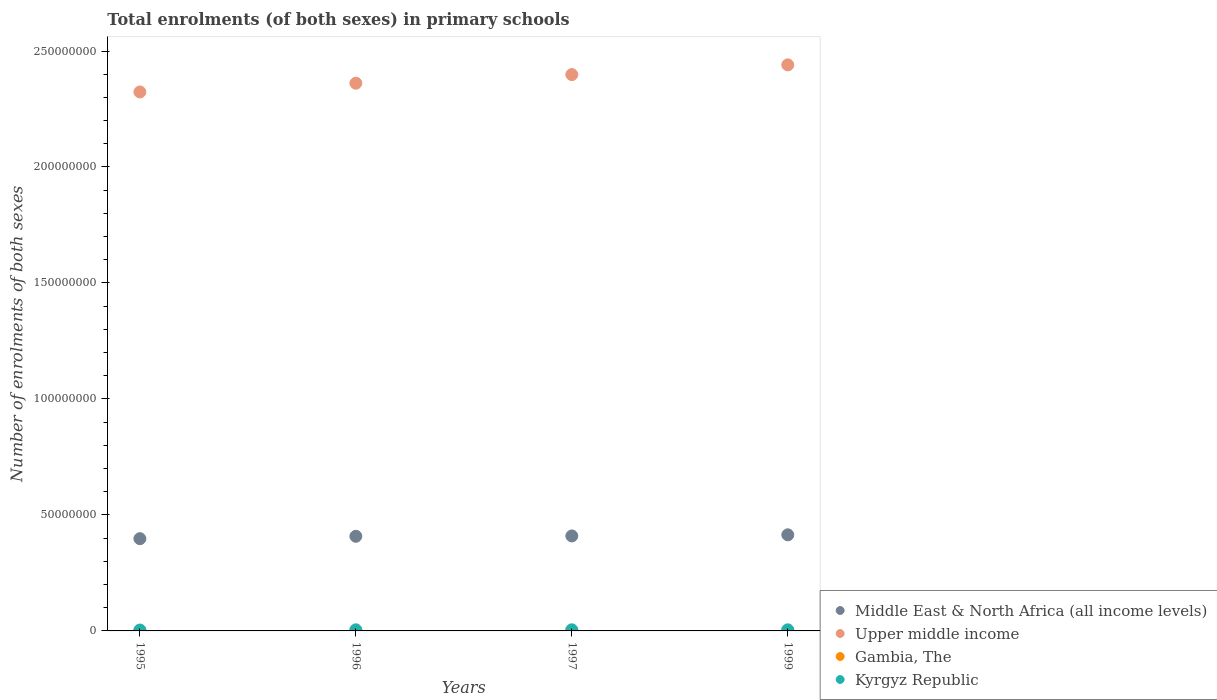Is the number of dotlines equal to the number of legend labels?
Make the answer very short. Yes. What is the number of enrolments in primary schools in Upper middle income in 1997?
Provide a short and direct response. 2.40e+08. Across all years, what is the maximum number of enrolments in primary schools in Gambia, The?
Give a very brief answer. 1.70e+05. Across all years, what is the minimum number of enrolments in primary schools in Middle East & North Africa (all income levels)?
Offer a terse response. 3.98e+07. In which year was the number of enrolments in primary schools in Upper middle income maximum?
Ensure brevity in your answer.  1999. In which year was the number of enrolments in primary schools in Gambia, The minimum?
Offer a very short reply. 1995. What is the total number of enrolments in primary schools in Kyrgyz Republic in the graph?
Your answer should be very brief. 1.81e+06. What is the difference between the number of enrolments in primary schools in Upper middle income in 1996 and that in 1999?
Give a very brief answer. -7.90e+06. What is the difference between the number of enrolments in primary schools in Kyrgyz Republic in 1995 and the number of enrolments in primary schools in Middle East & North Africa (all income levels) in 1997?
Keep it short and to the point. -4.06e+07. What is the average number of enrolments in primary schools in Gambia, The per year?
Give a very brief answer. 1.35e+05. In the year 1999, what is the difference between the number of enrolments in primary schools in Gambia, The and number of enrolments in primary schools in Middle East & North Africa (all income levels)?
Give a very brief answer. -4.13e+07. What is the ratio of the number of enrolments in primary schools in Gambia, The in 1996 to that in 1999?
Provide a short and direct response. 0.73. Is the number of enrolments in primary schools in Gambia, The in 1997 less than that in 1999?
Make the answer very short. Yes. What is the difference between the highest and the second highest number of enrolments in primary schools in Upper middle income?
Provide a short and direct response. 4.20e+06. What is the difference between the highest and the lowest number of enrolments in primary schools in Gambia, The?
Your answer should be compact. 5.71e+04. Is it the case that in every year, the sum of the number of enrolments in primary schools in Upper middle income and number of enrolments in primary schools in Kyrgyz Republic  is greater than the number of enrolments in primary schools in Gambia, The?
Provide a succinct answer. Yes. Is the number of enrolments in primary schools in Gambia, The strictly greater than the number of enrolments in primary schools in Middle East & North Africa (all income levels) over the years?
Offer a terse response. No. How many dotlines are there?
Provide a short and direct response. 4. How many years are there in the graph?
Make the answer very short. 4. What is the difference between two consecutive major ticks on the Y-axis?
Offer a terse response. 5.00e+07. Are the values on the major ticks of Y-axis written in scientific E-notation?
Your response must be concise. No. Does the graph contain any zero values?
Offer a very short reply. No. Does the graph contain grids?
Your answer should be compact. No. How many legend labels are there?
Provide a succinct answer. 4. What is the title of the graph?
Make the answer very short. Total enrolments (of both sexes) in primary schools. Does "Low income" appear as one of the legend labels in the graph?
Ensure brevity in your answer.  No. What is the label or title of the X-axis?
Offer a terse response. Years. What is the label or title of the Y-axis?
Your response must be concise. Number of enrolments of both sexes. What is the Number of enrolments of both sexes in Middle East & North Africa (all income levels) in 1995?
Make the answer very short. 3.98e+07. What is the Number of enrolments of both sexes in Upper middle income in 1995?
Your answer should be very brief. 2.32e+08. What is the Number of enrolments of both sexes in Gambia, The in 1995?
Your answer should be very brief. 1.13e+05. What is the Number of enrolments of both sexes of Kyrgyz Republic in 1995?
Give a very brief answer. 3.88e+05. What is the Number of enrolments of both sexes of Middle East & North Africa (all income levels) in 1996?
Your response must be concise. 4.08e+07. What is the Number of enrolments of both sexes of Upper middle income in 1996?
Your response must be concise. 2.36e+08. What is the Number of enrolments of both sexes of Gambia, The in 1996?
Offer a very short reply. 1.25e+05. What is the Number of enrolments of both sexes in Kyrgyz Republic in 1996?
Ensure brevity in your answer.  4.73e+05. What is the Number of enrolments of both sexes in Middle East & North Africa (all income levels) in 1997?
Your response must be concise. 4.09e+07. What is the Number of enrolments of both sexes of Upper middle income in 1997?
Keep it short and to the point. 2.40e+08. What is the Number of enrolments of both sexes of Gambia, The in 1997?
Give a very brief answer. 1.33e+05. What is the Number of enrolments of both sexes of Kyrgyz Republic in 1997?
Provide a succinct answer. 4.78e+05. What is the Number of enrolments of both sexes in Middle East & North Africa (all income levels) in 1999?
Make the answer very short. 4.14e+07. What is the Number of enrolments of both sexes in Upper middle income in 1999?
Give a very brief answer. 2.44e+08. What is the Number of enrolments of both sexes in Gambia, The in 1999?
Offer a terse response. 1.70e+05. What is the Number of enrolments of both sexes in Kyrgyz Republic in 1999?
Ensure brevity in your answer.  4.70e+05. Across all years, what is the maximum Number of enrolments of both sexes in Middle East & North Africa (all income levels)?
Your answer should be very brief. 4.14e+07. Across all years, what is the maximum Number of enrolments of both sexes in Upper middle income?
Keep it short and to the point. 2.44e+08. Across all years, what is the maximum Number of enrolments of both sexes of Gambia, The?
Ensure brevity in your answer.  1.70e+05. Across all years, what is the maximum Number of enrolments of both sexes of Kyrgyz Republic?
Your answer should be compact. 4.78e+05. Across all years, what is the minimum Number of enrolments of both sexes in Middle East & North Africa (all income levels)?
Offer a terse response. 3.98e+07. Across all years, what is the minimum Number of enrolments of both sexes of Upper middle income?
Give a very brief answer. 2.32e+08. Across all years, what is the minimum Number of enrolments of both sexes of Gambia, The?
Ensure brevity in your answer.  1.13e+05. Across all years, what is the minimum Number of enrolments of both sexes in Kyrgyz Republic?
Offer a very short reply. 3.88e+05. What is the total Number of enrolments of both sexes of Middle East & North Africa (all income levels) in the graph?
Offer a terse response. 1.63e+08. What is the total Number of enrolments of both sexes in Upper middle income in the graph?
Keep it short and to the point. 9.52e+08. What is the total Number of enrolments of both sexes in Gambia, The in the graph?
Offer a terse response. 5.42e+05. What is the total Number of enrolments of both sexes in Kyrgyz Republic in the graph?
Provide a succinct answer. 1.81e+06. What is the difference between the Number of enrolments of both sexes in Middle East & North Africa (all income levels) in 1995 and that in 1996?
Your response must be concise. -1.03e+06. What is the difference between the Number of enrolments of both sexes in Upper middle income in 1995 and that in 1996?
Your answer should be very brief. -3.78e+06. What is the difference between the Number of enrolments of both sexes in Gambia, The in 1995 and that in 1996?
Keep it short and to the point. -1.13e+04. What is the difference between the Number of enrolments of both sexes in Kyrgyz Republic in 1995 and that in 1996?
Your answer should be compact. -8.59e+04. What is the difference between the Number of enrolments of both sexes of Middle East & North Africa (all income levels) in 1995 and that in 1997?
Your response must be concise. -1.18e+06. What is the difference between the Number of enrolments of both sexes in Upper middle income in 1995 and that in 1997?
Ensure brevity in your answer.  -7.49e+06. What is the difference between the Number of enrolments of both sexes in Gambia, The in 1995 and that in 1997?
Provide a short and direct response. -2.02e+04. What is the difference between the Number of enrolments of both sexes in Kyrgyz Republic in 1995 and that in 1997?
Your response must be concise. -9.03e+04. What is the difference between the Number of enrolments of both sexes of Middle East & North Africa (all income levels) in 1995 and that in 1999?
Provide a succinct answer. -1.67e+06. What is the difference between the Number of enrolments of both sexes in Upper middle income in 1995 and that in 1999?
Offer a terse response. -1.17e+07. What is the difference between the Number of enrolments of both sexes of Gambia, The in 1995 and that in 1999?
Ensure brevity in your answer.  -5.71e+04. What is the difference between the Number of enrolments of both sexes in Kyrgyz Republic in 1995 and that in 1999?
Make the answer very short. -8.22e+04. What is the difference between the Number of enrolments of both sexes in Middle East & North Africa (all income levels) in 1996 and that in 1997?
Offer a very short reply. -1.48e+05. What is the difference between the Number of enrolments of both sexes of Upper middle income in 1996 and that in 1997?
Your answer should be very brief. -3.71e+06. What is the difference between the Number of enrolments of both sexes of Gambia, The in 1996 and that in 1997?
Give a very brief answer. -8896. What is the difference between the Number of enrolments of both sexes in Kyrgyz Republic in 1996 and that in 1997?
Make the answer very short. -4451. What is the difference between the Number of enrolments of both sexes in Middle East & North Africa (all income levels) in 1996 and that in 1999?
Ensure brevity in your answer.  -6.35e+05. What is the difference between the Number of enrolments of both sexes of Upper middle income in 1996 and that in 1999?
Your answer should be very brief. -7.90e+06. What is the difference between the Number of enrolments of both sexes in Gambia, The in 1996 and that in 1999?
Offer a terse response. -4.59e+04. What is the difference between the Number of enrolments of both sexes in Kyrgyz Republic in 1996 and that in 1999?
Your answer should be very brief. 3684. What is the difference between the Number of enrolments of both sexes of Middle East & North Africa (all income levels) in 1997 and that in 1999?
Provide a short and direct response. -4.87e+05. What is the difference between the Number of enrolments of both sexes in Upper middle income in 1997 and that in 1999?
Give a very brief answer. -4.20e+06. What is the difference between the Number of enrolments of both sexes in Gambia, The in 1997 and that in 1999?
Ensure brevity in your answer.  -3.70e+04. What is the difference between the Number of enrolments of both sexes of Kyrgyz Republic in 1997 and that in 1999?
Your answer should be very brief. 8135. What is the difference between the Number of enrolments of both sexes of Middle East & North Africa (all income levels) in 1995 and the Number of enrolments of both sexes of Upper middle income in 1996?
Make the answer very short. -1.96e+08. What is the difference between the Number of enrolments of both sexes in Middle East & North Africa (all income levels) in 1995 and the Number of enrolments of both sexes in Gambia, The in 1996?
Ensure brevity in your answer.  3.96e+07. What is the difference between the Number of enrolments of both sexes in Middle East & North Africa (all income levels) in 1995 and the Number of enrolments of both sexes in Kyrgyz Republic in 1996?
Your response must be concise. 3.93e+07. What is the difference between the Number of enrolments of both sexes in Upper middle income in 1995 and the Number of enrolments of both sexes in Gambia, The in 1996?
Your response must be concise. 2.32e+08. What is the difference between the Number of enrolments of both sexes in Upper middle income in 1995 and the Number of enrolments of both sexes in Kyrgyz Republic in 1996?
Your answer should be compact. 2.32e+08. What is the difference between the Number of enrolments of both sexes of Gambia, The in 1995 and the Number of enrolments of both sexes of Kyrgyz Republic in 1996?
Give a very brief answer. -3.60e+05. What is the difference between the Number of enrolments of both sexes of Middle East & North Africa (all income levels) in 1995 and the Number of enrolments of both sexes of Upper middle income in 1997?
Provide a succinct answer. -2.00e+08. What is the difference between the Number of enrolments of both sexes in Middle East & North Africa (all income levels) in 1995 and the Number of enrolments of both sexes in Gambia, The in 1997?
Ensure brevity in your answer.  3.96e+07. What is the difference between the Number of enrolments of both sexes of Middle East & North Africa (all income levels) in 1995 and the Number of enrolments of both sexes of Kyrgyz Republic in 1997?
Keep it short and to the point. 3.93e+07. What is the difference between the Number of enrolments of both sexes in Upper middle income in 1995 and the Number of enrolments of both sexes in Gambia, The in 1997?
Give a very brief answer. 2.32e+08. What is the difference between the Number of enrolments of both sexes of Upper middle income in 1995 and the Number of enrolments of both sexes of Kyrgyz Republic in 1997?
Provide a short and direct response. 2.32e+08. What is the difference between the Number of enrolments of both sexes of Gambia, The in 1995 and the Number of enrolments of both sexes of Kyrgyz Republic in 1997?
Make the answer very short. -3.65e+05. What is the difference between the Number of enrolments of both sexes of Middle East & North Africa (all income levels) in 1995 and the Number of enrolments of both sexes of Upper middle income in 1999?
Your answer should be compact. -2.04e+08. What is the difference between the Number of enrolments of both sexes of Middle East & North Africa (all income levels) in 1995 and the Number of enrolments of both sexes of Gambia, The in 1999?
Ensure brevity in your answer.  3.96e+07. What is the difference between the Number of enrolments of both sexes of Middle East & North Africa (all income levels) in 1995 and the Number of enrolments of both sexes of Kyrgyz Republic in 1999?
Provide a succinct answer. 3.93e+07. What is the difference between the Number of enrolments of both sexes of Upper middle income in 1995 and the Number of enrolments of both sexes of Gambia, The in 1999?
Give a very brief answer. 2.32e+08. What is the difference between the Number of enrolments of both sexes of Upper middle income in 1995 and the Number of enrolments of both sexes of Kyrgyz Republic in 1999?
Make the answer very short. 2.32e+08. What is the difference between the Number of enrolments of both sexes in Gambia, The in 1995 and the Number of enrolments of both sexes in Kyrgyz Republic in 1999?
Your answer should be very brief. -3.57e+05. What is the difference between the Number of enrolments of both sexes in Middle East & North Africa (all income levels) in 1996 and the Number of enrolments of both sexes in Upper middle income in 1997?
Keep it short and to the point. -1.99e+08. What is the difference between the Number of enrolments of both sexes of Middle East & North Africa (all income levels) in 1996 and the Number of enrolments of both sexes of Gambia, The in 1997?
Your answer should be compact. 4.07e+07. What is the difference between the Number of enrolments of both sexes of Middle East & North Africa (all income levels) in 1996 and the Number of enrolments of both sexes of Kyrgyz Republic in 1997?
Offer a very short reply. 4.03e+07. What is the difference between the Number of enrolments of both sexes in Upper middle income in 1996 and the Number of enrolments of both sexes in Gambia, The in 1997?
Make the answer very short. 2.36e+08. What is the difference between the Number of enrolments of both sexes of Upper middle income in 1996 and the Number of enrolments of both sexes of Kyrgyz Republic in 1997?
Provide a short and direct response. 2.36e+08. What is the difference between the Number of enrolments of both sexes in Gambia, The in 1996 and the Number of enrolments of both sexes in Kyrgyz Republic in 1997?
Keep it short and to the point. -3.53e+05. What is the difference between the Number of enrolments of both sexes of Middle East & North Africa (all income levels) in 1996 and the Number of enrolments of both sexes of Upper middle income in 1999?
Provide a succinct answer. -2.03e+08. What is the difference between the Number of enrolments of both sexes of Middle East & North Africa (all income levels) in 1996 and the Number of enrolments of both sexes of Gambia, The in 1999?
Make the answer very short. 4.06e+07. What is the difference between the Number of enrolments of both sexes in Middle East & North Africa (all income levels) in 1996 and the Number of enrolments of both sexes in Kyrgyz Republic in 1999?
Ensure brevity in your answer.  4.03e+07. What is the difference between the Number of enrolments of both sexes in Upper middle income in 1996 and the Number of enrolments of both sexes in Gambia, The in 1999?
Provide a succinct answer. 2.36e+08. What is the difference between the Number of enrolments of both sexes of Upper middle income in 1996 and the Number of enrolments of both sexes of Kyrgyz Republic in 1999?
Keep it short and to the point. 2.36e+08. What is the difference between the Number of enrolments of both sexes in Gambia, The in 1996 and the Number of enrolments of both sexes in Kyrgyz Republic in 1999?
Provide a succinct answer. -3.45e+05. What is the difference between the Number of enrolments of both sexes in Middle East & North Africa (all income levels) in 1997 and the Number of enrolments of both sexes in Upper middle income in 1999?
Offer a very short reply. -2.03e+08. What is the difference between the Number of enrolments of both sexes in Middle East & North Africa (all income levels) in 1997 and the Number of enrolments of both sexes in Gambia, The in 1999?
Keep it short and to the point. 4.08e+07. What is the difference between the Number of enrolments of both sexes of Middle East & North Africa (all income levels) in 1997 and the Number of enrolments of both sexes of Kyrgyz Republic in 1999?
Ensure brevity in your answer.  4.05e+07. What is the difference between the Number of enrolments of both sexes of Upper middle income in 1997 and the Number of enrolments of both sexes of Gambia, The in 1999?
Your answer should be very brief. 2.40e+08. What is the difference between the Number of enrolments of both sexes of Upper middle income in 1997 and the Number of enrolments of both sexes of Kyrgyz Republic in 1999?
Your response must be concise. 2.39e+08. What is the difference between the Number of enrolments of both sexes in Gambia, The in 1997 and the Number of enrolments of both sexes in Kyrgyz Republic in 1999?
Your response must be concise. -3.36e+05. What is the average Number of enrolments of both sexes of Middle East & North Africa (all income levels) per year?
Your answer should be compact. 4.07e+07. What is the average Number of enrolments of both sexes in Upper middle income per year?
Give a very brief answer. 2.38e+08. What is the average Number of enrolments of both sexes of Gambia, The per year?
Offer a very short reply. 1.35e+05. What is the average Number of enrolments of both sexes of Kyrgyz Republic per year?
Keep it short and to the point. 4.52e+05. In the year 1995, what is the difference between the Number of enrolments of both sexes in Middle East & North Africa (all income levels) and Number of enrolments of both sexes in Upper middle income?
Provide a succinct answer. -1.93e+08. In the year 1995, what is the difference between the Number of enrolments of both sexes in Middle East & North Africa (all income levels) and Number of enrolments of both sexes in Gambia, The?
Give a very brief answer. 3.97e+07. In the year 1995, what is the difference between the Number of enrolments of both sexes in Middle East & North Africa (all income levels) and Number of enrolments of both sexes in Kyrgyz Republic?
Your answer should be very brief. 3.94e+07. In the year 1995, what is the difference between the Number of enrolments of both sexes in Upper middle income and Number of enrolments of both sexes in Gambia, The?
Your answer should be compact. 2.32e+08. In the year 1995, what is the difference between the Number of enrolments of both sexes of Upper middle income and Number of enrolments of both sexes of Kyrgyz Republic?
Give a very brief answer. 2.32e+08. In the year 1995, what is the difference between the Number of enrolments of both sexes of Gambia, The and Number of enrolments of both sexes of Kyrgyz Republic?
Keep it short and to the point. -2.74e+05. In the year 1996, what is the difference between the Number of enrolments of both sexes in Middle East & North Africa (all income levels) and Number of enrolments of both sexes in Upper middle income?
Offer a terse response. -1.95e+08. In the year 1996, what is the difference between the Number of enrolments of both sexes in Middle East & North Africa (all income levels) and Number of enrolments of both sexes in Gambia, The?
Ensure brevity in your answer.  4.07e+07. In the year 1996, what is the difference between the Number of enrolments of both sexes in Middle East & North Africa (all income levels) and Number of enrolments of both sexes in Kyrgyz Republic?
Keep it short and to the point. 4.03e+07. In the year 1996, what is the difference between the Number of enrolments of both sexes of Upper middle income and Number of enrolments of both sexes of Gambia, The?
Provide a short and direct response. 2.36e+08. In the year 1996, what is the difference between the Number of enrolments of both sexes of Upper middle income and Number of enrolments of both sexes of Kyrgyz Republic?
Offer a terse response. 2.36e+08. In the year 1996, what is the difference between the Number of enrolments of both sexes of Gambia, The and Number of enrolments of both sexes of Kyrgyz Republic?
Give a very brief answer. -3.49e+05. In the year 1997, what is the difference between the Number of enrolments of both sexes of Middle East & North Africa (all income levels) and Number of enrolments of both sexes of Upper middle income?
Offer a very short reply. -1.99e+08. In the year 1997, what is the difference between the Number of enrolments of both sexes of Middle East & North Africa (all income levels) and Number of enrolments of both sexes of Gambia, The?
Give a very brief answer. 4.08e+07. In the year 1997, what is the difference between the Number of enrolments of both sexes of Middle East & North Africa (all income levels) and Number of enrolments of both sexes of Kyrgyz Republic?
Your answer should be very brief. 4.05e+07. In the year 1997, what is the difference between the Number of enrolments of both sexes in Upper middle income and Number of enrolments of both sexes in Gambia, The?
Your response must be concise. 2.40e+08. In the year 1997, what is the difference between the Number of enrolments of both sexes in Upper middle income and Number of enrolments of both sexes in Kyrgyz Republic?
Make the answer very short. 2.39e+08. In the year 1997, what is the difference between the Number of enrolments of both sexes of Gambia, The and Number of enrolments of both sexes of Kyrgyz Republic?
Your answer should be compact. -3.45e+05. In the year 1999, what is the difference between the Number of enrolments of both sexes of Middle East & North Africa (all income levels) and Number of enrolments of both sexes of Upper middle income?
Ensure brevity in your answer.  -2.03e+08. In the year 1999, what is the difference between the Number of enrolments of both sexes of Middle East & North Africa (all income levels) and Number of enrolments of both sexes of Gambia, The?
Offer a very short reply. 4.13e+07. In the year 1999, what is the difference between the Number of enrolments of both sexes in Middle East & North Africa (all income levels) and Number of enrolments of both sexes in Kyrgyz Republic?
Provide a short and direct response. 4.10e+07. In the year 1999, what is the difference between the Number of enrolments of both sexes in Upper middle income and Number of enrolments of both sexes in Gambia, The?
Your answer should be very brief. 2.44e+08. In the year 1999, what is the difference between the Number of enrolments of both sexes of Upper middle income and Number of enrolments of both sexes of Kyrgyz Republic?
Your answer should be very brief. 2.44e+08. In the year 1999, what is the difference between the Number of enrolments of both sexes in Gambia, The and Number of enrolments of both sexes in Kyrgyz Republic?
Give a very brief answer. -2.99e+05. What is the ratio of the Number of enrolments of both sexes of Middle East & North Africa (all income levels) in 1995 to that in 1996?
Give a very brief answer. 0.97. What is the ratio of the Number of enrolments of both sexes of Upper middle income in 1995 to that in 1996?
Make the answer very short. 0.98. What is the ratio of the Number of enrolments of both sexes of Gambia, The in 1995 to that in 1996?
Keep it short and to the point. 0.91. What is the ratio of the Number of enrolments of both sexes of Kyrgyz Republic in 1995 to that in 1996?
Your answer should be very brief. 0.82. What is the ratio of the Number of enrolments of both sexes of Middle East & North Africa (all income levels) in 1995 to that in 1997?
Keep it short and to the point. 0.97. What is the ratio of the Number of enrolments of both sexes of Upper middle income in 1995 to that in 1997?
Make the answer very short. 0.97. What is the ratio of the Number of enrolments of both sexes in Gambia, The in 1995 to that in 1997?
Make the answer very short. 0.85. What is the ratio of the Number of enrolments of both sexes of Kyrgyz Republic in 1995 to that in 1997?
Provide a short and direct response. 0.81. What is the ratio of the Number of enrolments of both sexes of Middle East & North Africa (all income levels) in 1995 to that in 1999?
Keep it short and to the point. 0.96. What is the ratio of the Number of enrolments of both sexes of Upper middle income in 1995 to that in 1999?
Your answer should be very brief. 0.95. What is the ratio of the Number of enrolments of both sexes of Gambia, The in 1995 to that in 1999?
Ensure brevity in your answer.  0.66. What is the ratio of the Number of enrolments of both sexes of Kyrgyz Republic in 1995 to that in 1999?
Provide a succinct answer. 0.82. What is the ratio of the Number of enrolments of both sexes of Upper middle income in 1996 to that in 1997?
Ensure brevity in your answer.  0.98. What is the ratio of the Number of enrolments of both sexes of Kyrgyz Republic in 1996 to that in 1997?
Your response must be concise. 0.99. What is the ratio of the Number of enrolments of both sexes of Middle East & North Africa (all income levels) in 1996 to that in 1999?
Give a very brief answer. 0.98. What is the ratio of the Number of enrolments of both sexes of Upper middle income in 1996 to that in 1999?
Offer a very short reply. 0.97. What is the ratio of the Number of enrolments of both sexes in Gambia, The in 1996 to that in 1999?
Your answer should be compact. 0.73. What is the ratio of the Number of enrolments of both sexes of Upper middle income in 1997 to that in 1999?
Make the answer very short. 0.98. What is the ratio of the Number of enrolments of both sexes of Gambia, The in 1997 to that in 1999?
Give a very brief answer. 0.78. What is the ratio of the Number of enrolments of both sexes in Kyrgyz Republic in 1997 to that in 1999?
Provide a short and direct response. 1.02. What is the difference between the highest and the second highest Number of enrolments of both sexes of Middle East & North Africa (all income levels)?
Make the answer very short. 4.87e+05. What is the difference between the highest and the second highest Number of enrolments of both sexes of Upper middle income?
Provide a succinct answer. 4.20e+06. What is the difference between the highest and the second highest Number of enrolments of both sexes of Gambia, The?
Make the answer very short. 3.70e+04. What is the difference between the highest and the second highest Number of enrolments of both sexes of Kyrgyz Republic?
Provide a short and direct response. 4451. What is the difference between the highest and the lowest Number of enrolments of both sexes in Middle East & North Africa (all income levels)?
Offer a very short reply. 1.67e+06. What is the difference between the highest and the lowest Number of enrolments of both sexes of Upper middle income?
Your answer should be very brief. 1.17e+07. What is the difference between the highest and the lowest Number of enrolments of both sexes in Gambia, The?
Offer a terse response. 5.71e+04. What is the difference between the highest and the lowest Number of enrolments of both sexes of Kyrgyz Republic?
Give a very brief answer. 9.03e+04. 